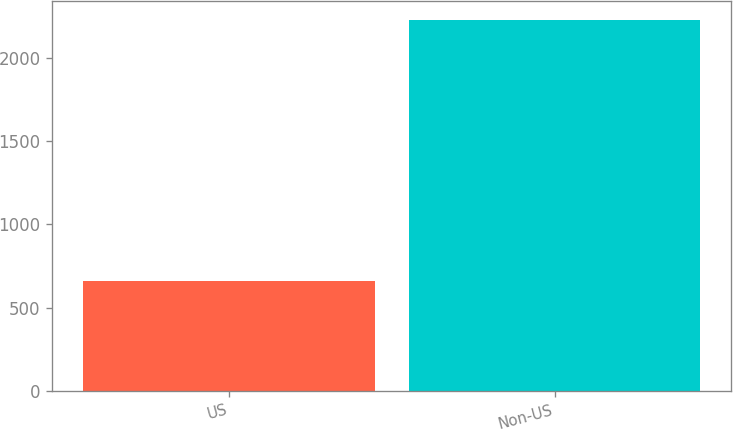Convert chart. <chart><loc_0><loc_0><loc_500><loc_500><bar_chart><fcel>US<fcel>Non-US<nl><fcel>661<fcel>2227<nl></chart> 